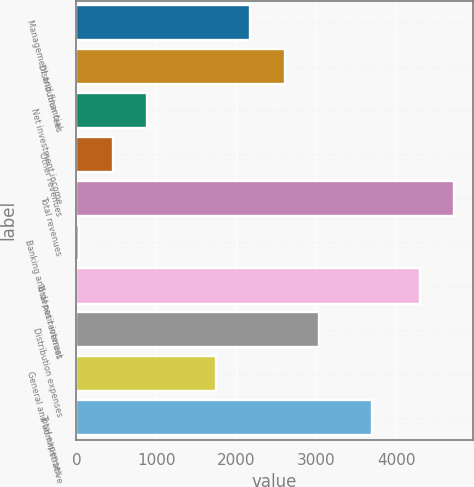<chart> <loc_0><loc_0><loc_500><loc_500><bar_chart><fcel>Management and financial<fcel>Distribution fees<fcel>Net investment income<fcel>Other revenues<fcel>Total revenues<fcel>Banking and deposit interest<fcel>Total net revenues<fcel>Distribution expenses<fcel>General and administrative<fcel>Total expenses<nl><fcel>2178.5<fcel>2608<fcel>890<fcel>460.5<fcel>4724.5<fcel>31<fcel>4295<fcel>3037.5<fcel>1749<fcel>3703<nl></chart> 